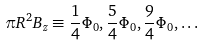Convert formula to latex. <formula><loc_0><loc_0><loc_500><loc_500>\pi R ^ { 2 } B _ { z } \equiv \frac { 1 } { 4 } \Phi _ { 0 } , \frac { 5 } { 4 } \Phi _ { 0 } , \frac { 9 } { 4 } \Phi _ { 0 } , \dots</formula> 